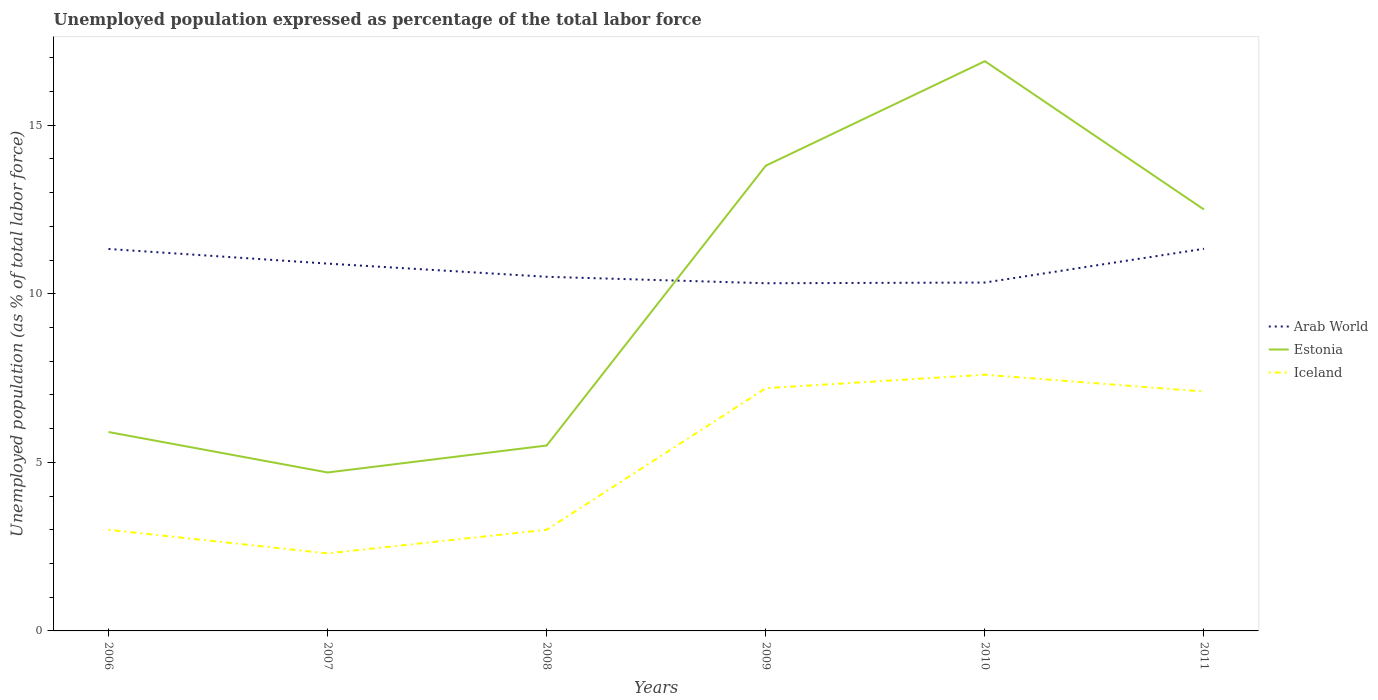How many different coloured lines are there?
Offer a very short reply. 3. Does the line corresponding to Iceland intersect with the line corresponding to Estonia?
Your answer should be very brief. No. Across all years, what is the maximum unemployment in in Iceland?
Offer a terse response. 2.3. What is the total unemployment in in Iceland in the graph?
Your response must be concise. -4.8. What is the difference between the highest and the second highest unemployment in in Iceland?
Offer a very short reply. 5.3. How many years are there in the graph?
Provide a short and direct response. 6. What is the difference between two consecutive major ticks on the Y-axis?
Provide a succinct answer. 5. Does the graph contain any zero values?
Give a very brief answer. No. Does the graph contain grids?
Offer a terse response. No. Where does the legend appear in the graph?
Provide a succinct answer. Center right. How many legend labels are there?
Your answer should be compact. 3. How are the legend labels stacked?
Ensure brevity in your answer.  Vertical. What is the title of the graph?
Ensure brevity in your answer.  Unemployed population expressed as percentage of the total labor force. What is the label or title of the Y-axis?
Offer a terse response. Unemployed population (as % of total labor force). What is the Unemployed population (as % of total labor force) in Arab World in 2006?
Your answer should be very brief. 11.33. What is the Unemployed population (as % of total labor force) in Estonia in 2006?
Your answer should be very brief. 5.9. What is the Unemployed population (as % of total labor force) in Arab World in 2007?
Your response must be concise. 10.9. What is the Unemployed population (as % of total labor force) in Estonia in 2007?
Give a very brief answer. 4.7. What is the Unemployed population (as % of total labor force) of Iceland in 2007?
Provide a short and direct response. 2.3. What is the Unemployed population (as % of total labor force) of Arab World in 2008?
Keep it short and to the point. 10.5. What is the Unemployed population (as % of total labor force) in Arab World in 2009?
Give a very brief answer. 10.31. What is the Unemployed population (as % of total labor force) of Estonia in 2009?
Your answer should be compact. 13.8. What is the Unemployed population (as % of total labor force) of Iceland in 2009?
Keep it short and to the point. 7.2. What is the Unemployed population (as % of total labor force) of Arab World in 2010?
Ensure brevity in your answer.  10.33. What is the Unemployed population (as % of total labor force) in Estonia in 2010?
Provide a short and direct response. 16.9. What is the Unemployed population (as % of total labor force) of Iceland in 2010?
Provide a succinct answer. 7.6. What is the Unemployed population (as % of total labor force) in Arab World in 2011?
Make the answer very short. 11.34. What is the Unemployed population (as % of total labor force) of Iceland in 2011?
Provide a succinct answer. 7.1. Across all years, what is the maximum Unemployed population (as % of total labor force) of Arab World?
Keep it short and to the point. 11.34. Across all years, what is the maximum Unemployed population (as % of total labor force) of Estonia?
Give a very brief answer. 16.9. Across all years, what is the maximum Unemployed population (as % of total labor force) in Iceland?
Ensure brevity in your answer.  7.6. Across all years, what is the minimum Unemployed population (as % of total labor force) of Arab World?
Keep it short and to the point. 10.31. Across all years, what is the minimum Unemployed population (as % of total labor force) of Estonia?
Your answer should be very brief. 4.7. Across all years, what is the minimum Unemployed population (as % of total labor force) of Iceland?
Keep it short and to the point. 2.3. What is the total Unemployed population (as % of total labor force) in Arab World in the graph?
Ensure brevity in your answer.  64.71. What is the total Unemployed population (as % of total labor force) of Estonia in the graph?
Give a very brief answer. 59.3. What is the total Unemployed population (as % of total labor force) in Iceland in the graph?
Keep it short and to the point. 30.2. What is the difference between the Unemployed population (as % of total labor force) in Arab World in 2006 and that in 2007?
Your answer should be very brief. 0.43. What is the difference between the Unemployed population (as % of total labor force) in Arab World in 2006 and that in 2008?
Offer a very short reply. 0.82. What is the difference between the Unemployed population (as % of total labor force) in Arab World in 2006 and that in 2009?
Provide a short and direct response. 1.02. What is the difference between the Unemployed population (as % of total labor force) in Arab World in 2006 and that in 2010?
Offer a terse response. 1. What is the difference between the Unemployed population (as % of total labor force) in Estonia in 2006 and that in 2010?
Make the answer very short. -11. What is the difference between the Unemployed population (as % of total labor force) in Arab World in 2006 and that in 2011?
Give a very brief answer. -0.01. What is the difference between the Unemployed population (as % of total labor force) in Estonia in 2006 and that in 2011?
Make the answer very short. -6.6. What is the difference between the Unemployed population (as % of total labor force) of Arab World in 2007 and that in 2008?
Your response must be concise. 0.39. What is the difference between the Unemployed population (as % of total labor force) of Iceland in 2007 and that in 2008?
Provide a short and direct response. -0.7. What is the difference between the Unemployed population (as % of total labor force) of Arab World in 2007 and that in 2009?
Ensure brevity in your answer.  0.58. What is the difference between the Unemployed population (as % of total labor force) of Arab World in 2007 and that in 2010?
Provide a succinct answer. 0.56. What is the difference between the Unemployed population (as % of total labor force) of Estonia in 2007 and that in 2010?
Your answer should be very brief. -12.2. What is the difference between the Unemployed population (as % of total labor force) of Iceland in 2007 and that in 2010?
Your answer should be compact. -5.3. What is the difference between the Unemployed population (as % of total labor force) in Arab World in 2007 and that in 2011?
Give a very brief answer. -0.44. What is the difference between the Unemployed population (as % of total labor force) of Estonia in 2007 and that in 2011?
Your answer should be very brief. -7.8. What is the difference between the Unemployed population (as % of total labor force) of Arab World in 2008 and that in 2009?
Keep it short and to the point. 0.19. What is the difference between the Unemployed population (as % of total labor force) in Iceland in 2008 and that in 2009?
Provide a succinct answer. -4.2. What is the difference between the Unemployed population (as % of total labor force) of Arab World in 2008 and that in 2010?
Your answer should be very brief. 0.17. What is the difference between the Unemployed population (as % of total labor force) in Estonia in 2008 and that in 2010?
Offer a terse response. -11.4. What is the difference between the Unemployed population (as % of total labor force) in Arab World in 2008 and that in 2011?
Make the answer very short. -0.83. What is the difference between the Unemployed population (as % of total labor force) of Arab World in 2009 and that in 2010?
Your answer should be very brief. -0.02. What is the difference between the Unemployed population (as % of total labor force) in Arab World in 2009 and that in 2011?
Your answer should be compact. -1.02. What is the difference between the Unemployed population (as % of total labor force) of Estonia in 2009 and that in 2011?
Ensure brevity in your answer.  1.3. What is the difference between the Unemployed population (as % of total labor force) in Arab World in 2010 and that in 2011?
Provide a short and direct response. -1. What is the difference between the Unemployed population (as % of total labor force) of Arab World in 2006 and the Unemployed population (as % of total labor force) of Estonia in 2007?
Your answer should be very brief. 6.63. What is the difference between the Unemployed population (as % of total labor force) of Arab World in 2006 and the Unemployed population (as % of total labor force) of Iceland in 2007?
Provide a short and direct response. 9.03. What is the difference between the Unemployed population (as % of total labor force) of Estonia in 2006 and the Unemployed population (as % of total labor force) of Iceland in 2007?
Offer a terse response. 3.6. What is the difference between the Unemployed population (as % of total labor force) of Arab World in 2006 and the Unemployed population (as % of total labor force) of Estonia in 2008?
Give a very brief answer. 5.83. What is the difference between the Unemployed population (as % of total labor force) of Arab World in 2006 and the Unemployed population (as % of total labor force) of Iceland in 2008?
Your answer should be very brief. 8.33. What is the difference between the Unemployed population (as % of total labor force) of Arab World in 2006 and the Unemployed population (as % of total labor force) of Estonia in 2009?
Keep it short and to the point. -2.47. What is the difference between the Unemployed population (as % of total labor force) in Arab World in 2006 and the Unemployed population (as % of total labor force) in Iceland in 2009?
Keep it short and to the point. 4.13. What is the difference between the Unemployed population (as % of total labor force) of Arab World in 2006 and the Unemployed population (as % of total labor force) of Estonia in 2010?
Ensure brevity in your answer.  -5.57. What is the difference between the Unemployed population (as % of total labor force) in Arab World in 2006 and the Unemployed population (as % of total labor force) in Iceland in 2010?
Provide a short and direct response. 3.73. What is the difference between the Unemployed population (as % of total labor force) of Arab World in 2006 and the Unemployed population (as % of total labor force) of Estonia in 2011?
Give a very brief answer. -1.17. What is the difference between the Unemployed population (as % of total labor force) of Arab World in 2006 and the Unemployed population (as % of total labor force) of Iceland in 2011?
Make the answer very short. 4.23. What is the difference between the Unemployed population (as % of total labor force) of Arab World in 2007 and the Unemployed population (as % of total labor force) of Estonia in 2008?
Ensure brevity in your answer.  5.4. What is the difference between the Unemployed population (as % of total labor force) in Arab World in 2007 and the Unemployed population (as % of total labor force) in Iceland in 2008?
Provide a succinct answer. 7.9. What is the difference between the Unemployed population (as % of total labor force) in Estonia in 2007 and the Unemployed population (as % of total labor force) in Iceland in 2008?
Provide a short and direct response. 1.7. What is the difference between the Unemployed population (as % of total labor force) in Arab World in 2007 and the Unemployed population (as % of total labor force) in Estonia in 2009?
Offer a very short reply. -2.9. What is the difference between the Unemployed population (as % of total labor force) of Arab World in 2007 and the Unemployed population (as % of total labor force) of Iceland in 2009?
Ensure brevity in your answer.  3.7. What is the difference between the Unemployed population (as % of total labor force) in Estonia in 2007 and the Unemployed population (as % of total labor force) in Iceland in 2009?
Your response must be concise. -2.5. What is the difference between the Unemployed population (as % of total labor force) of Arab World in 2007 and the Unemployed population (as % of total labor force) of Estonia in 2010?
Your answer should be very brief. -6. What is the difference between the Unemployed population (as % of total labor force) in Arab World in 2007 and the Unemployed population (as % of total labor force) in Iceland in 2010?
Your response must be concise. 3.3. What is the difference between the Unemployed population (as % of total labor force) in Estonia in 2007 and the Unemployed population (as % of total labor force) in Iceland in 2010?
Your answer should be very brief. -2.9. What is the difference between the Unemployed population (as % of total labor force) of Arab World in 2007 and the Unemployed population (as % of total labor force) of Estonia in 2011?
Offer a terse response. -1.6. What is the difference between the Unemployed population (as % of total labor force) of Arab World in 2007 and the Unemployed population (as % of total labor force) of Iceland in 2011?
Offer a terse response. 3.8. What is the difference between the Unemployed population (as % of total labor force) in Arab World in 2008 and the Unemployed population (as % of total labor force) in Estonia in 2009?
Offer a very short reply. -3.3. What is the difference between the Unemployed population (as % of total labor force) in Arab World in 2008 and the Unemployed population (as % of total labor force) in Iceland in 2009?
Your response must be concise. 3.3. What is the difference between the Unemployed population (as % of total labor force) in Estonia in 2008 and the Unemployed population (as % of total labor force) in Iceland in 2009?
Provide a short and direct response. -1.7. What is the difference between the Unemployed population (as % of total labor force) of Arab World in 2008 and the Unemployed population (as % of total labor force) of Estonia in 2010?
Keep it short and to the point. -6.4. What is the difference between the Unemployed population (as % of total labor force) of Arab World in 2008 and the Unemployed population (as % of total labor force) of Iceland in 2010?
Offer a very short reply. 2.9. What is the difference between the Unemployed population (as % of total labor force) of Estonia in 2008 and the Unemployed population (as % of total labor force) of Iceland in 2010?
Your answer should be compact. -2.1. What is the difference between the Unemployed population (as % of total labor force) of Arab World in 2008 and the Unemployed population (as % of total labor force) of Estonia in 2011?
Offer a terse response. -2. What is the difference between the Unemployed population (as % of total labor force) of Arab World in 2008 and the Unemployed population (as % of total labor force) of Iceland in 2011?
Offer a very short reply. 3.4. What is the difference between the Unemployed population (as % of total labor force) of Estonia in 2008 and the Unemployed population (as % of total labor force) of Iceland in 2011?
Offer a terse response. -1.6. What is the difference between the Unemployed population (as % of total labor force) in Arab World in 2009 and the Unemployed population (as % of total labor force) in Estonia in 2010?
Make the answer very short. -6.59. What is the difference between the Unemployed population (as % of total labor force) of Arab World in 2009 and the Unemployed population (as % of total labor force) of Iceland in 2010?
Your answer should be compact. 2.71. What is the difference between the Unemployed population (as % of total labor force) of Estonia in 2009 and the Unemployed population (as % of total labor force) of Iceland in 2010?
Provide a succinct answer. 6.2. What is the difference between the Unemployed population (as % of total labor force) of Arab World in 2009 and the Unemployed population (as % of total labor force) of Estonia in 2011?
Your answer should be compact. -2.19. What is the difference between the Unemployed population (as % of total labor force) in Arab World in 2009 and the Unemployed population (as % of total labor force) in Iceland in 2011?
Give a very brief answer. 3.21. What is the difference between the Unemployed population (as % of total labor force) of Arab World in 2010 and the Unemployed population (as % of total labor force) of Estonia in 2011?
Offer a very short reply. -2.17. What is the difference between the Unemployed population (as % of total labor force) of Arab World in 2010 and the Unemployed population (as % of total labor force) of Iceland in 2011?
Provide a short and direct response. 3.23. What is the difference between the Unemployed population (as % of total labor force) in Estonia in 2010 and the Unemployed population (as % of total labor force) in Iceland in 2011?
Give a very brief answer. 9.8. What is the average Unemployed population (as % of total labor force) in Arab World per year?
Your answer should be compact. 10.79. What is the average Unemployed population (as % of total labor force) in Estonia per year?
Your answer should be compact. 9.88. What is the average Unemployed population (as % of total labor force) of Iceland per year?
Ensure brevity in your answer.  5.03. In the year 2006, what is the difference between the Unemployed population (as % of total labor force) in Arab World and Unemployed population (as % of total labor force) in Estonia?
Make the answer very short. 5.43. In the year 2006, what is the difference between the Unemployed population (as % of total labor force) in Arab World and Unemployed population (as % of total labor force) in Iceland?
Offer a terse response. 8.33. In the year 2006, what is the difference between the Unemployed population (as % of total labor force) of Estonia and Unemployed population (as % of total labor force) of Iceland?
Give a very brief answer. 2.9. In the year 2007, what is the difference between the Unemployed population (as % of total labor force) of Arab World and Unemployed population (as % of total labor force) of Estonia?
Offer a terse response. 6.2. In the year 2007, what is the difference between the Unemployed population (as % of total labor force) in Arab World and Unemployed population (as % of total labor force) in Iceland?
Offer a terse response. 8.6. In the year 2007, what is the difference between the Unemployed population (as % of total labor force) of Estonia and Unemployed population (as % of total labor force) of Iceland?
Give a very brief answer. 2.4. In the year 2008, what is the difference between the Unemployed population (as % of total labor force) in Arab World and Unemployed population (as % of total labor force) in Estonia?
Ensure brevity in your answer.  5. In the year 2008, what is the difference between the Unemployed population (as % of total labor force) of Arab World and Unemployed population (as % of total labor force) of Iceland?
Your answer should be compact. 7.5. In the year 2008, what is the difference between the Unemployed population (as % of total labor force) in Estonia and Unemployed population (as % of total labor force) in Iceland?
Ensure brevity in your answer.  2.5. In the year 2009, what is the difference between the Unemployed population (as % of total labor force) of Arab World and Unemployed population (as % of total labor force) of Estonia?
Keep it short and to the point. -3.49. In the year 2009, what is the difference between the Unemployed population (as % of total labor force) of Arab World and Unemployed population (as % of total labor force) of Iceland?
Offer a very short reply. 3.11. In the year 2010, what is the difference between the Unemployed population (as % of total labor force) of Arab World and Unemployed population (as % of total labor force) of Estonia?
Offer a terse response. -6.57. In the year 2010, what is the difference between the Unemployed population (as % of total labor force) of Arab World and Unemployed population (as % of total labor force) of Iceland?
Keep it short and to the point. 2.73. In the year 2011, what is the difference between the Unemployed population (as % of total labor force) of Arab World and Unemployed population (as % of total labor force) of Estonia?
Your response must be concise. -1.16. In the year 2011, what is the difference between the Unemployed population (as % of total labor force) of Arab World and Unemployed population (as % of total labor force) of Iceland?
Your answer should be very brief. 4.24. What is the ratio of the Unemployed population (as % of total labor force) of Arab World in 2006 to that in 2007?
Offer a terse response. 1.04. What is the ratio of the Unemployed population (as % of total labor force) in Estonia in 2006 to that in 2007?
Your response must be concise. 1.26. What is the ratio of the Unemployed population (as % of total labor force) in Iceland in 2006 to that in 2007?
Offer a terse response. 1.3. What is the ratio of the Unemployed population (as % of total labor force) in Arab World in 2006 to that in 2008?
Provide a succinct answer. 1.08. What is the ratio of the Unemployed population (as % of total labor force) in Estonia in 2006 to that in 2008?
Your answer should be compact. 1.07. What is the ratio of the Unemployed population (as % of total labor force) of Arab World in 2006 to that in 2009?
Your answer should be very brief. 1.1. What is the ratio of the Unemployed population (as % of total labor force) of Estonia in 2006 to that in 2009?
Provide a short and direct response. 0.43. What is the ratio of the Unemployed population (as % of total labor force) of Iceland in 2006 to that in 2009?
Offer a terse response. 0.42. What is the ratio of the Unemployed population (as % of total labor force) in Arab World in 2006 to that in 2010?
Give a very brief answer. 1.1. What is the ratio of the Unemployed population (as % of total labor force) in Estonia in 2006 to that in 2010?
Provide a succinct answer. 0.35. What is the ratio of the Unemployed population (as % of total labor force) in Iceland in 2006 to that in 2010?
Make the answer very short. 0.39. What is the ratio of the Unemployed population (as % of total labor force) of Arab World in 2006 to that in 2011?
Your response must be concise. 1. What is the ratio of the Unemployed population (as % of total labor force) in Estonia in 2006 to that in 2011?
Your answer should be compact. 0.47. What is the ratio of the Unemployed population (as % of total labor force) of Iceland in 2006 to that in 2011?
Provide a succinct answer. 0.42. What is the ratio of the Unemployed population (as % of total labor force) in Arab World in 2007 to that in 2008?
Make the answer very short. 1.04. What is the ratio of the Unemployed population (as % of total labor force) in Estonia in 2007 to that in 2008?
Offer a terse response. 0.85. What is the ratio of the Unemployed population (as % of total labor force) in Iceland in 2007 to that in 2008?
Offer a terse response. 0.77. What is the ratio of the Unemployed population (as % of total labor force) in Arab World in 2007 to that in 2009?
Your answer should be compact. 1.06. What is the ratio of the Unemployed population (as % of total labor force) of Estonia in 2007 to that in 2009?
Keep it short and to the point. 0.34. What is the ratio of the Unemployed population (as % of total labor force) of Iceland in 2007 to that in 2009?
Your answer should be very brief. 0.32. What is the ratio of the Unemployed population (as % of total labor force) in Arab World in 2007 to that in 2010?
Provide a short and direct response. 1.05. What is the ratio of the Unemployed population (as % of total labor force) of Estonia in 2007 to that in 2010?
Offer a very short reply. 0.28. What is the ratio of the Unemployed population (as % of total labor force) of Iceland in 2007 to that in 2010?
Provide a short and direct response. 0.3. What is the ratio of the Unemployed population (as % of total labor force) of Arab World in 2007 to that in 2011?
Provide a short and direct response. 0.96. What is the ratio of the Unemployed population (as % of total labor force) of Estonia in 2007 to that in 2011?
Provide a succinct answer. 0.38. What is the ratio of the Unemployed population (as % of total labor force) in Iceland in 2007 to that in 2011?
Give a very brief answer. 0.32. What is the ratio of the Unemployed population (as % of total labor force) of Arab World in 2008 to that in 2009?
Ensure brevity in your answer.  1.02. What is the ratio of the Unemployed population (as % of total labor force) in Estonia in 2008 to that in 2009?
Ensure brevity in your answer.  0.4. What is the ratio of the Unemployed population (as % of total labor force) of Iceland in 2008 to that in 2009?
Keep it short and to the point. 0.42. What is the ratio of the Unemployed population (as % of total labor force) of Arab World in 2008 to that in 2010?
Ensure brevity in your answer.  1.02. What is the ratio of the Unemployed population (as % of total labor force) in Estonia in 2008 to that in 2010?
Your answer should be compact. 0.33. What is the ratio of the Unemployed population (as % of total labor force) in Iceland in 2008 to that in 2010?
Give a very brief answer. 0.39. What is the ratio of the Unemployed population (as % of total labor force) of Arab World in 2008 to that in 2011?
Provide a succinct answer. 0.93. What is the ratio of the Unemployed population (as % of total labor force) in Estonia in 2008 to that in 2011?
Your response must be concise. 0.44. What is the ratio of the Unemployed population (as % of total labor force) of Iceland in 2008 to that in 2011?
Offer a very short reply. 0.42. What is the ratio of the Unemployed population (as % of total labor force) in Estonia in 2009 to that in 2010?
Give a very brief answer. 0.82. What is the ratio of the Unemployed population (as % of total labor force) of Iceland in 2009 to that in 2010?
Give a very brief answer. 0.95. What is the ratio of the Unemployed population (as % of total labor force) of Arab World in 2009 to that in 2011?
Provide a succinct answer. 0.91. What is the ratio of the Unemployed population (as % of total labor force) of Estonia in 2009 to that in 2011?
Make the answer very short. 1.1. What is the ratio of the Unemployed population (as % of total labor force) in Iceland in 2009 to that in 2011?
Make the answer very short. 1.01. What is the ratio of the Unemployed population (as % of total labor force) of Arab World in 2010 to that in 2011?
Offer a very short reply. 0.91. What is the ratio of the Unemployed population (as % of total labor force) in Estonia in 2010 to that in 2011?
Give a very brief answer. 1.35. What is the ratio of the Unemployed population (as % of total labor force) of Iceland in 2010 to that in 2011?
Provide a short and direct response. 1.07. What is the difference between the highest and the second highest Unemployed population (as % of total labor force) of Arab World?
Provide a succinct answer. 0.01. What is the difference between the highest and the lowest Unemployed population (as % of total labor force) of Arab World?
Provide a succinct answer. 1.02. What is the difference between the highest and the lowest Unemployed population (as % of total labor force) of Estonia?
Offer a terse response. 12.2. 